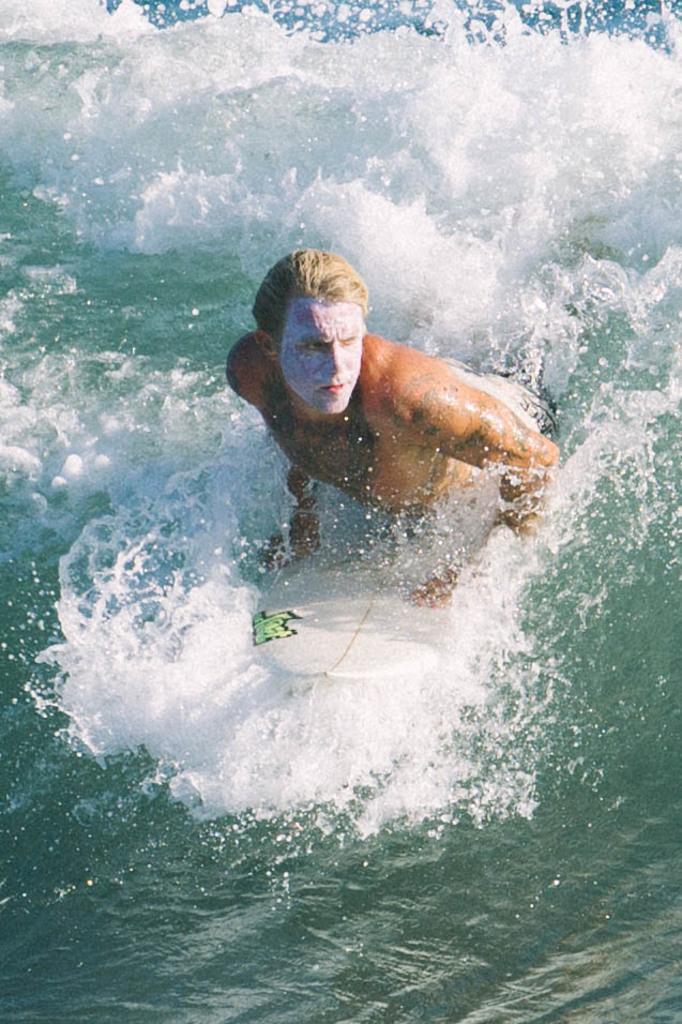How would you summarize this image in a sentence or two? In this picture we can see a man on the surfing board and this is water. 